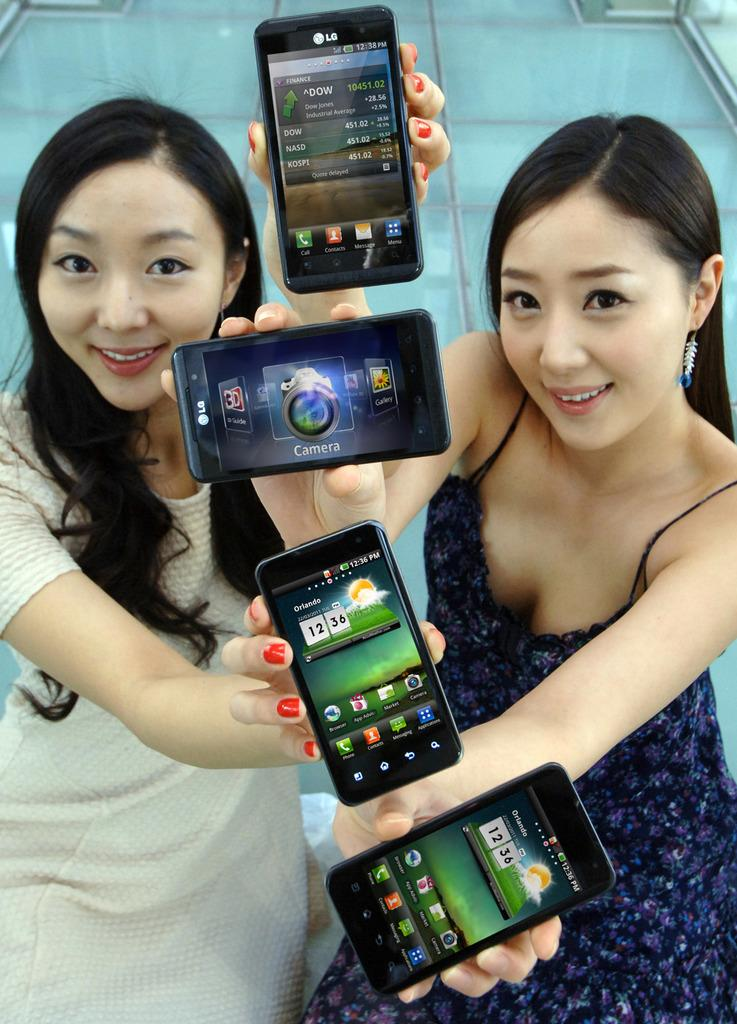<image>
Share a concise interpretation of the image provided. Two girls holding up four different devices, two are LGs and two are showing the weather for Orlando. 